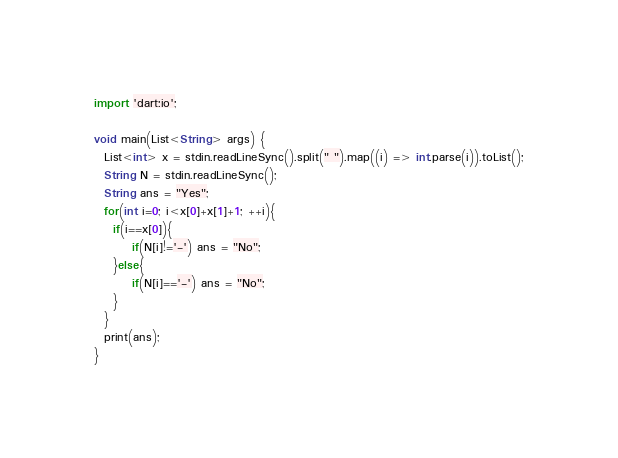<code> <loc_0><loc_0><loc_500><loc_500><_Dart_>import 'dart:io';
 
void main(List<String> args) {
  List<int> x = stdin.readLineSync().split(" ").map((i) => int.parse(i)).toList();
  String N = stdin.readLineSync();
  String ans = "Yes";
  for(int i=0; i<x[0]+x[1]+1; ++i){
    if(i==x[0]){
    	if(N[i]!='-') ans = "No";
    }else{
    	if(N[i]=='-') ans = "No";
    }
  }
  print(ans);
}</code> 